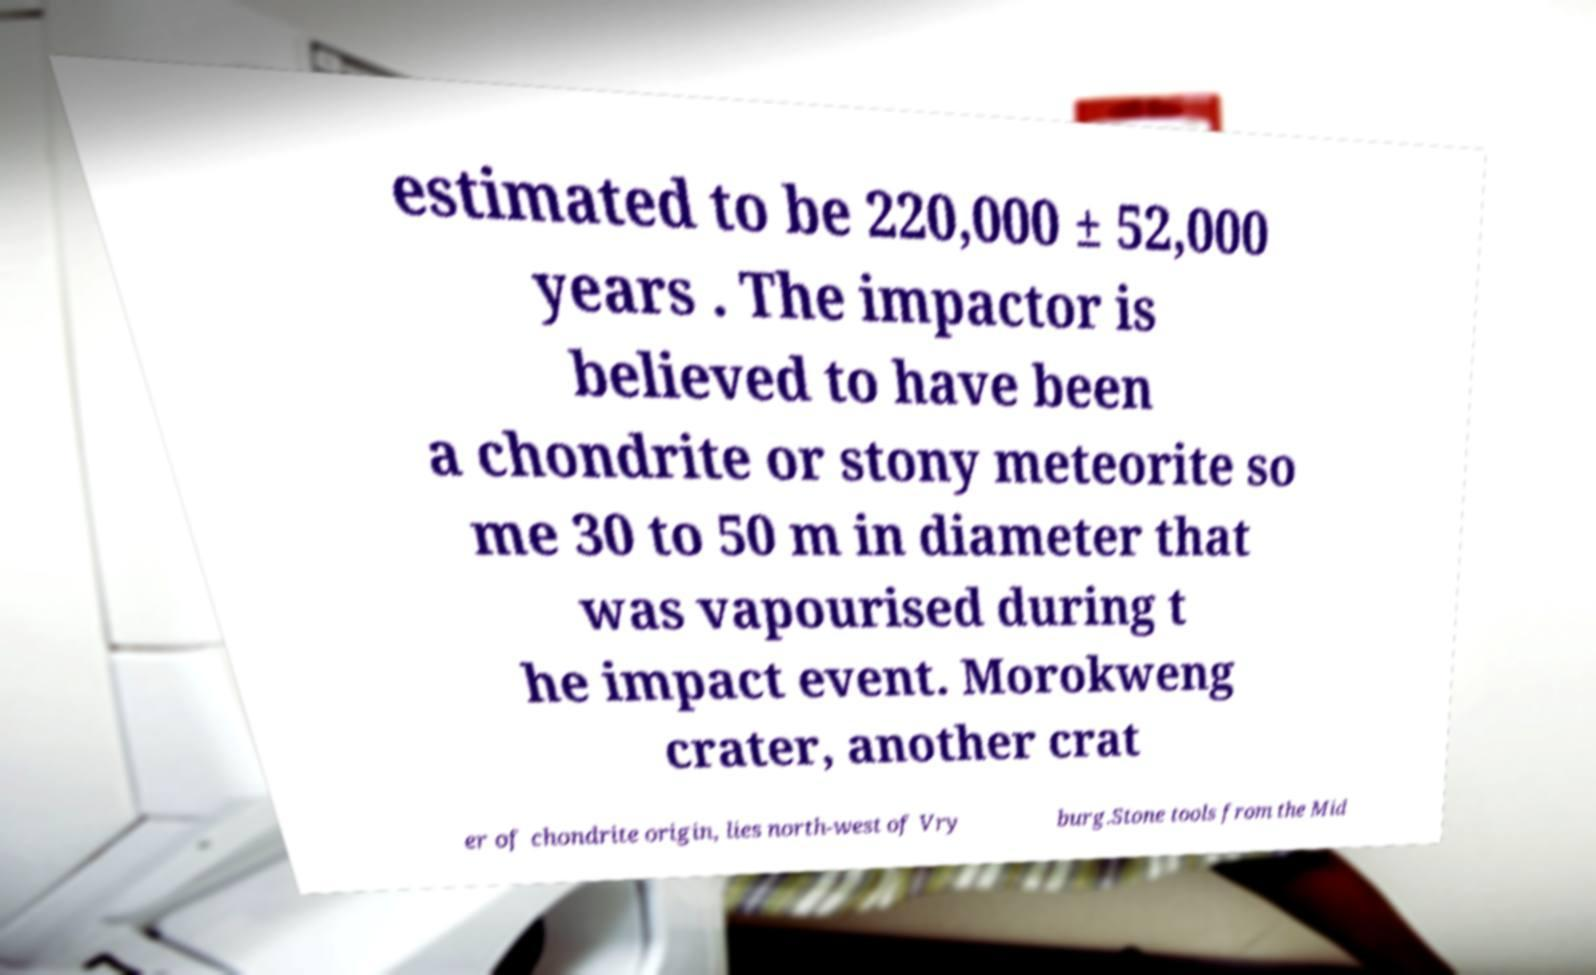For documentation purposes, I need the text within this image transcribed. Could you provide that? estimated to be 220,000 ± 52,000 years . The impactor is believed to have been a chondrite or stony meteorite so me 30 to 50 m in diameter that was vapourised during t he impact event. Morokweng crater, another crat er of chondrite origin, lies north-west of Vry burg.Stone tools from the Mid 